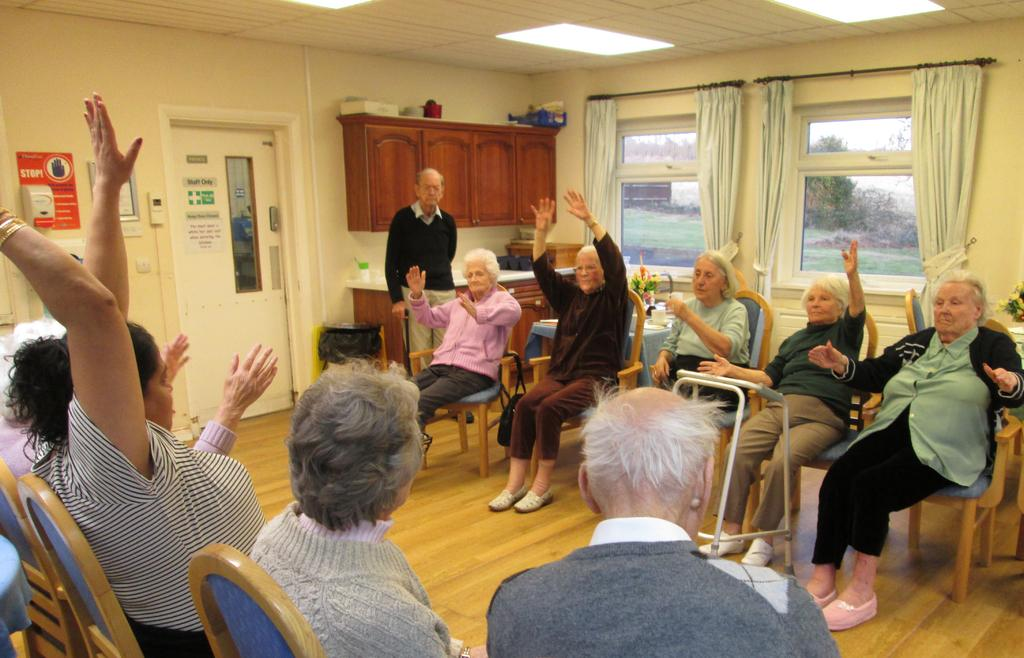What are the people in the image doing? The people in the image are sitting on chairs. Can you describe the man in the room? There is a man standing in the room. What type of window treatment is present in the image? There are curtains on the wall in the image. What type of dock can be seen in the image? There is no dock present in the image. How many beetles are crawling on the man's shoulder in the image? There are no beetles present in the image. 